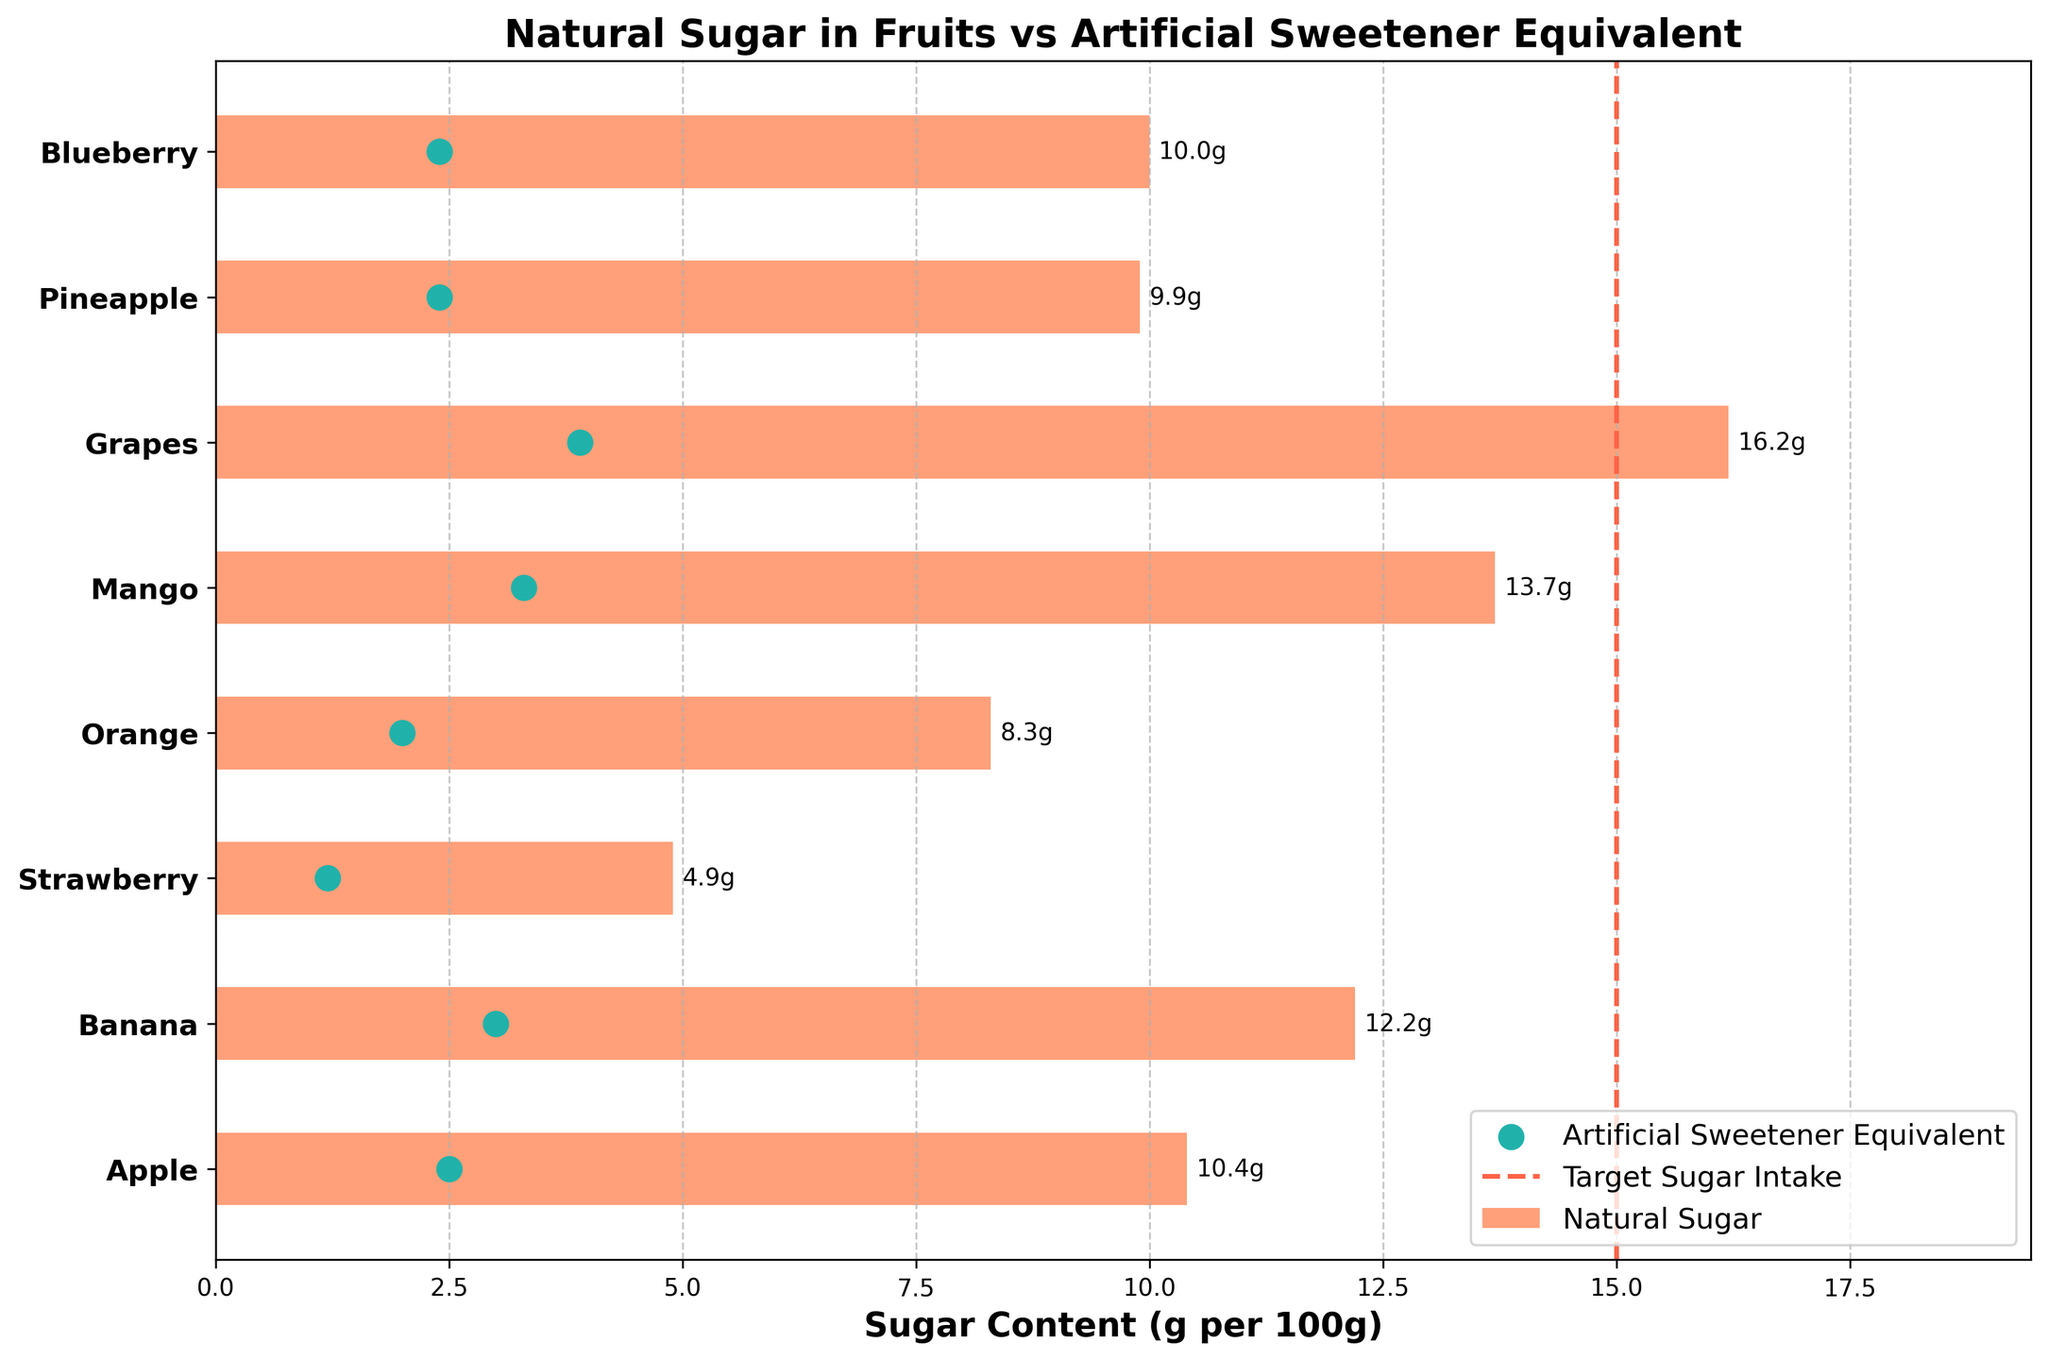What is the title of the chart? The title is typically displayed at the top of the chart and summarizes the main topic of the visual.
Answer: Natural Sugar in Fruits vs Artificial Sweetener Equivalent Which fruit has the highest natural sugar content? Identify the longest horizontal bar on the chart, which represents the natural sugar content for each fruit.
Answer: Grapes How much natural sugar does an orange contain compared to its artificial sweetener equivalent? Look at the horizontal bar and the marker for orange; for natural sugar, find the number on the bar, and for the artificial sweetener, find the marker.
Answer: 8.3g (Natural), 2.0g (Artificial Sweetener) Which fruit's natural sugar content exceeds the target sugar intake? Find any horizontal bars that extend beyond the vertical target sugar intake line at 15g.
Answer: Grapes How much artificial sweetener is equivalent to the natural sugar content in bananas? Check the markers representing artificial sweetener for the banana entry.
Answer: 3.0g Which fruit has the smallest difference between its natural sugar content and the target sugar intake? Calculate the difference between the natural sugar content for each fruit and the target (15g), then find the smallest difference.
Answer: Mango (1.3g difference) What is the combined total of natural sugar content for apple and strawberry? Summing the natural sugar content of apples and strawberries by looking at the lengths of their bars. 10.4g (Apple) + 4.9g (Strawberry).
Answer: 15.3g How do strawberries compare to pineapples in terms of natural sugar content? Compare the lengths of the horizontal bars for strawberries and pineapples, respectively.
Answer: Strawberries have less sugar What is the average natural sugar content of all the listed fruits? Add the natural sugar content of all the fruits and divide by the number of fruits: (10.4 + 12.2 + 4.9 + 8.3 + 13.7 + 16.2 + 9.9 + 10.0) / 8.
Answer: 10.7g 